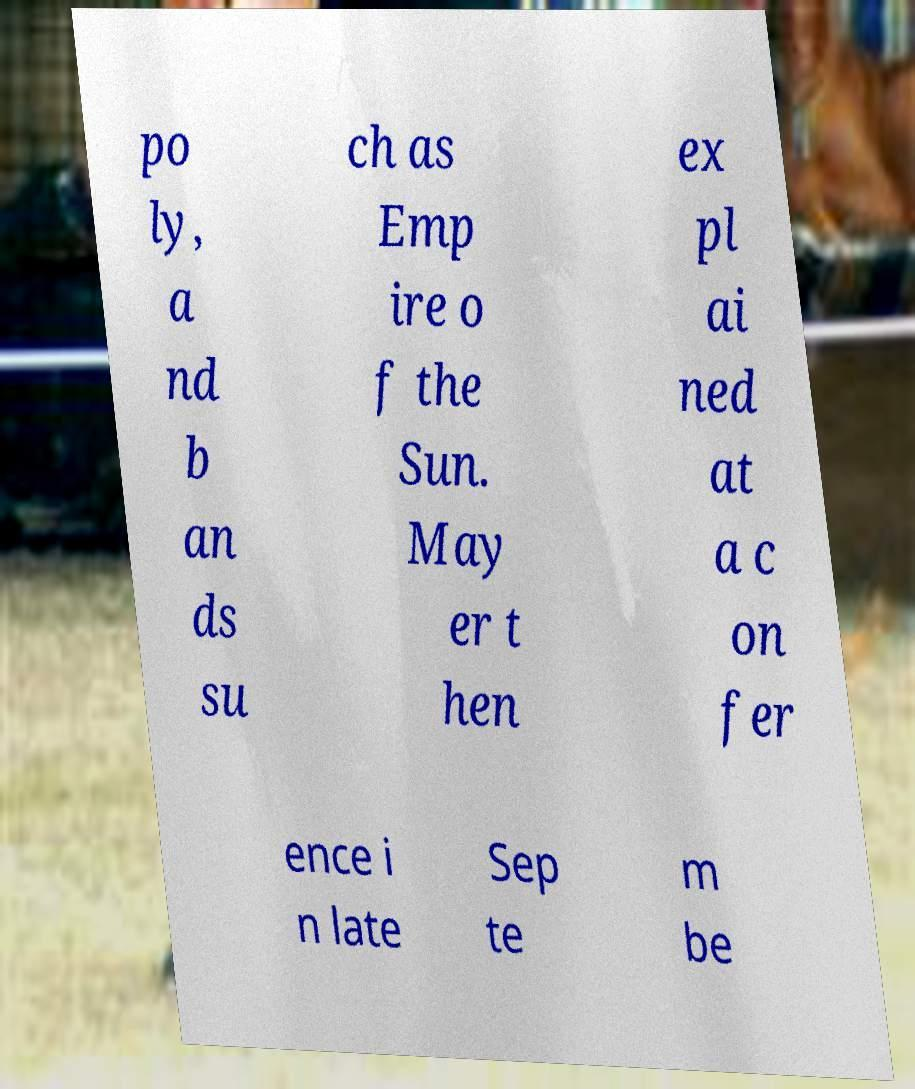For documentation purposes, I need the text within this image transcribed. Could you provide that? po ly, a nd b an ds su ch as Emp ire o f the Sun. May er t hen ex pl ai ned at a c on fer ence i n late Sep te m be 